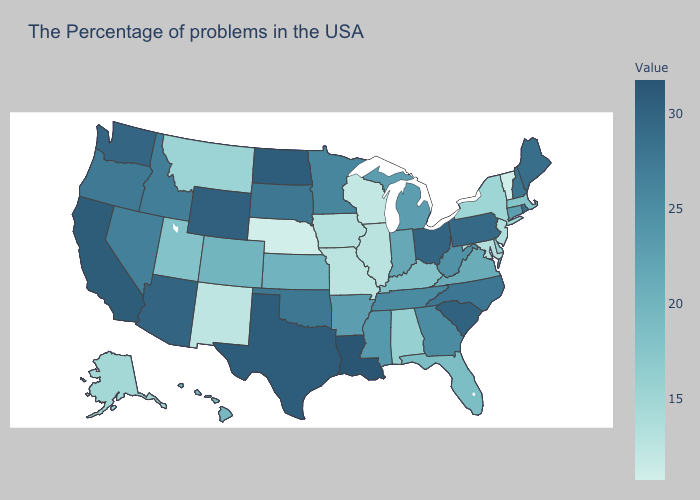Does the map have missing data?
Answer briefly. No. Which states have the highest value in the USA?
Answer briefly. Louisiana. Does the map have missing data?
Concise answer only. No. Does Florida have a higher value than Georgia?
Write a very short answer. No. Among the states that border North Carolina , does Virginia have the highest value?
Short answer required. No. Does New York have the lowest value in the USA?
Concise answer only. No. 